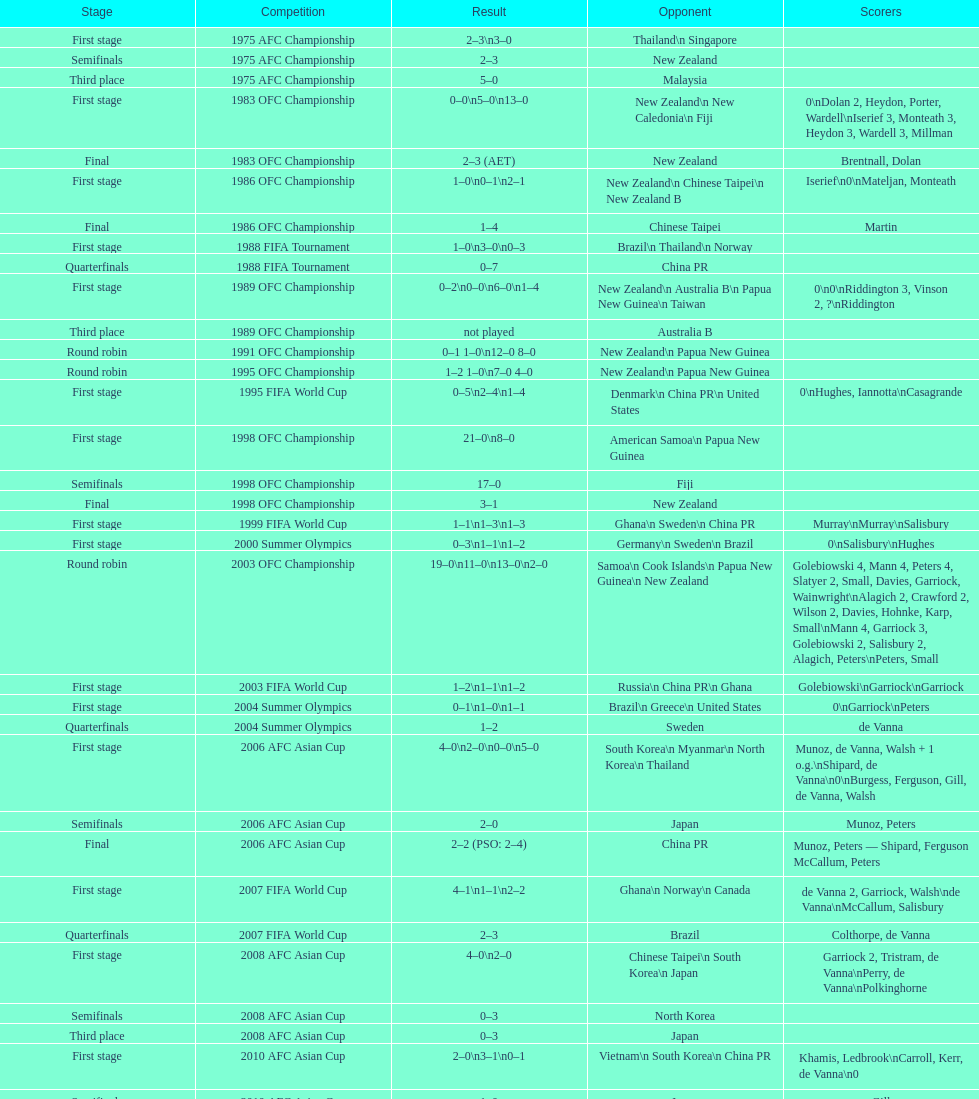What is the difference in the number of goals scored in the 1999 fifa world cup and the 2000 summer olympics? 2. 